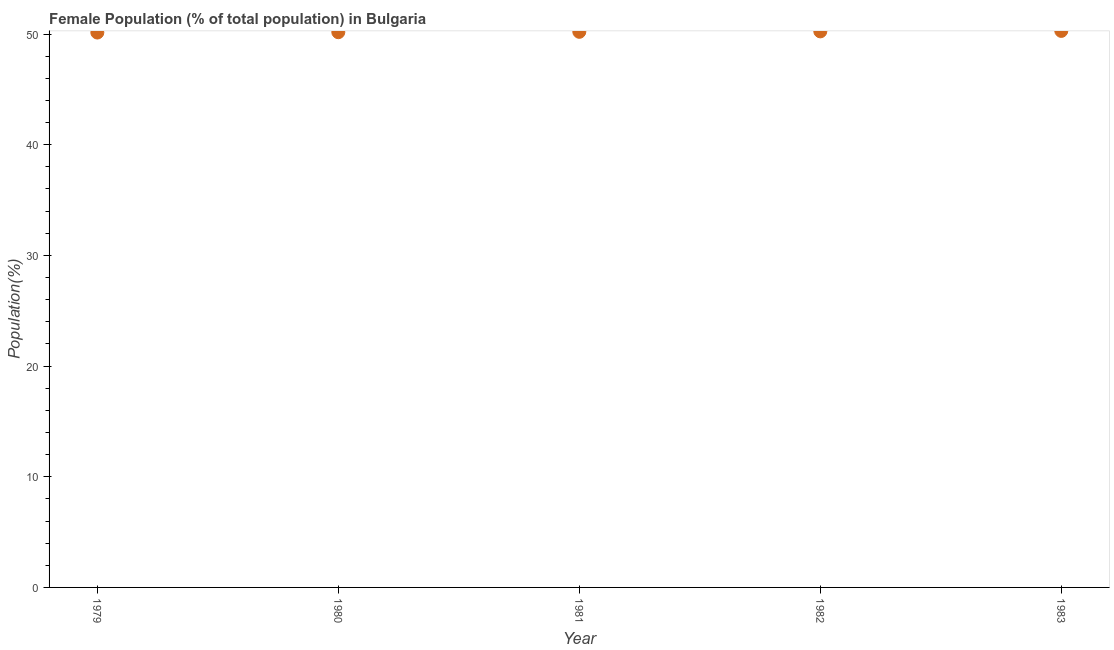What is the female population in 1979?
Your response must be concise. 50.13. Across all years, what is the maximum female population?
Ensure brevity in your answer.  50.28. Across all years, what is the minimum female population?
Your answer should be compact. 50.13. In which year was the female population maximum?
Provide a short and direct response. 1983. In which year was the female population minimum?
Your answer should be very brief. 1979. What is the sum of the female population?
Ensure brevity in your answer.  251.01. What is the difference between the female population in 1979 and 1980?
Ensure brevity in your answer.  -0.03. What is the average female population per year?
Give a very brief answer. 50.2. What is the median female population?
Keep it short and to the point. 50.2. In how many years, is the female population greater than 42 %?
Your answer should be compact. 5. Do a majority of the years between 1980 and 1982 (inclusive) have female population greater than 20 %?
Give a very brief answer. Yes. What is the ratio of the female population in 1981 to that in 1983?
Provide a succinct answer. 1. What is the difference between the highest and the second highest female population?
Make the answer very short. 0.04. What is the difference between the highest and the lowest female population?
Provide a succinct answer. 0.15. In how many years, is the female population greater than the average female population taken over all years?
Ensure brevity in your answer.  2. Are the values on the major ticks of Y-axis written in scientific E-notation?
Keep it short and to the point. No. Does the graph contain grids?
Give a very brief answer. No. What is the title of the graph?
Offer a terse response. Female Population (% of total population) in Bulgaria. What is the label or title of the Y-axis?
Offer a very short reply. Population(%). What is the Population(%) in 1979?
Provide a short and direct response. 50.13. What is the Population(%) in 1980?
Your answer should be very brief. 50.16. What is the Population(%) in 1981?
Ensure brevity in your answer.  50.2. What is the Population(%) in 1982?
Your answer should be very brief. 50.24. What is the Population(%) in 1983?
Offer a very short reply. 50.28. What is the difference between the Population(%) in 1979 and 1980?
Your answer should be very brief. -0.03. What is the difference between the Population(%) in 1979 and 1981?
Your answer should be compact. -0.06. What is the difference between the Population(%) in 1979 and 1982?
Provide a succinct answer. -0.1. What is the difference between the Population(%) in 1979 and 1983?
Make the answer very short. -0.15. What is the difference between the Population(%) in 1980 and 1981?
Offer a terse response. -0.03. What is the difference between the Population(%) in 1980 and 1982?
Ensure brevity in your answer.  -0.07. What is the difference between the Population(%) in 1980 and 1983?
Ensure brevity in your answer.  -0.12. What is the difference between the Population(%) in 1981 and 1982?
Keep it short and to the point. -0.04. What is the difference between the Population(%) in 1981 and 1983?
Offer a very short reply. -0.08. What is the difference between the Population(%) in 1982 and 1983?
Offer a very short reply. -0.04. What is the ratio of the Population(%) in 1979 to that in 1982?
Make the answer very short. 1. What is the ratio of the Population(%) in 1979 to that in 1983?
Provide a short and direct response. 1. What is the ratio of the Population(%) in 1980 to that in 1982?
Offer a very short reply. 1. What is the ratio of the Population(%) in 1980 to that in 1983?
Keep it short and to the point. 1. What is the ratio of the Population(%) in 1981 to that in 1983?
Keep it short and to the point. 1. What is the ratio of the Population(%) in 1982 to that in 1983?
Offer a very short reply. 1. 